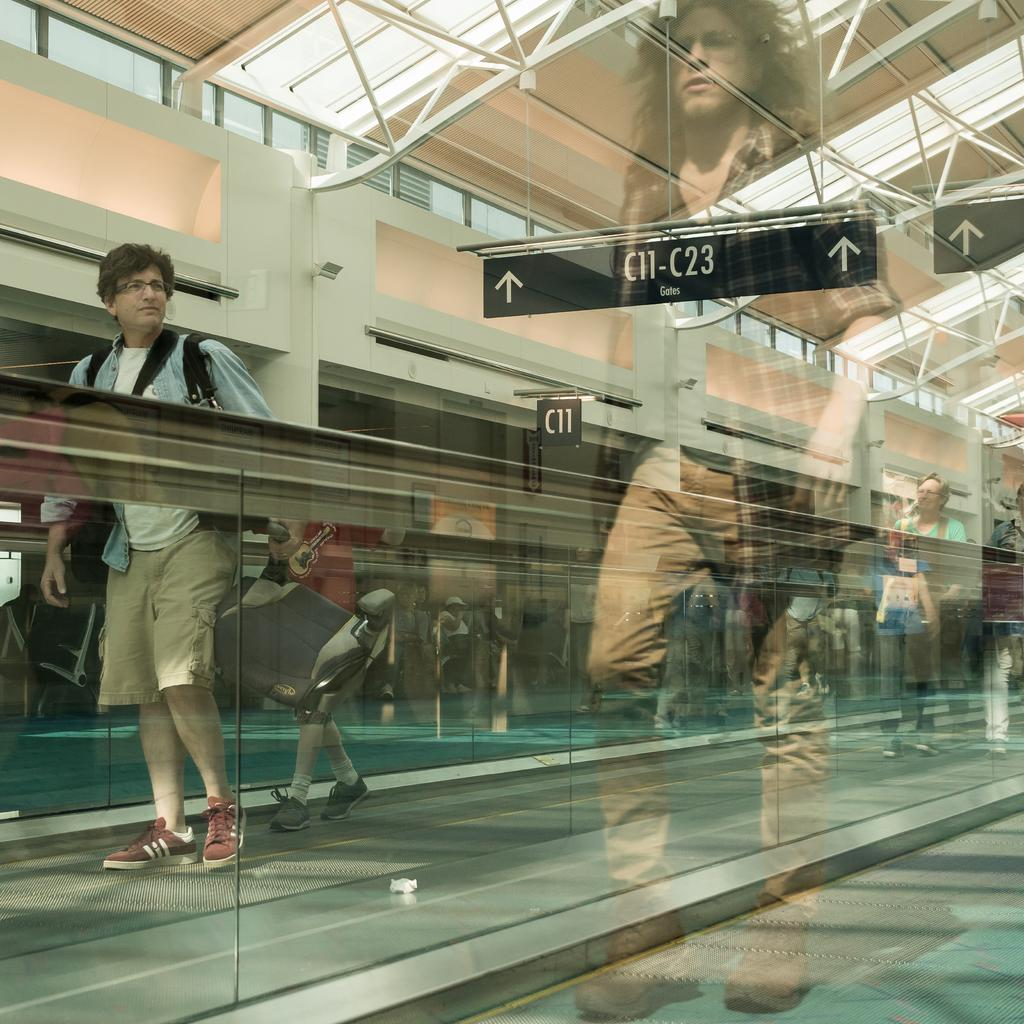Who or what is present in the image? There is a person in the image. What is the person wearing? The person is wearing a dress with blue, white, and brown colors. What is in front of the person? There is a glass wall in front of the person. What color is the background wall? The background wall is white. What grade is the person in the image? There is no information about the person's grade in the image. What type of vessel is present in the image? There is no vessel present in the image. 